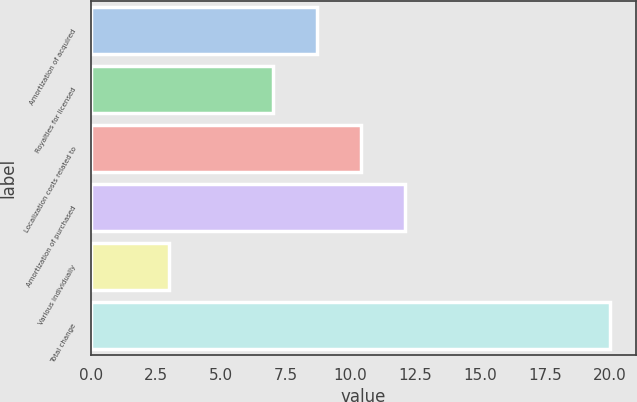<chart> <loc_0><loc_0><loc_500><loc_500><bar_chart><fcel>Amortization of acquired<fcel>Royalties for licensed<fcel>Localization costs related to<fcel>Amortization of purchased<fcel>Various individually<fcel>Total change<nl><fcel>8.7<fcel>7<fcel>10.4<fcel>12.1<fcel>3<fcel>20<nl></chart> 